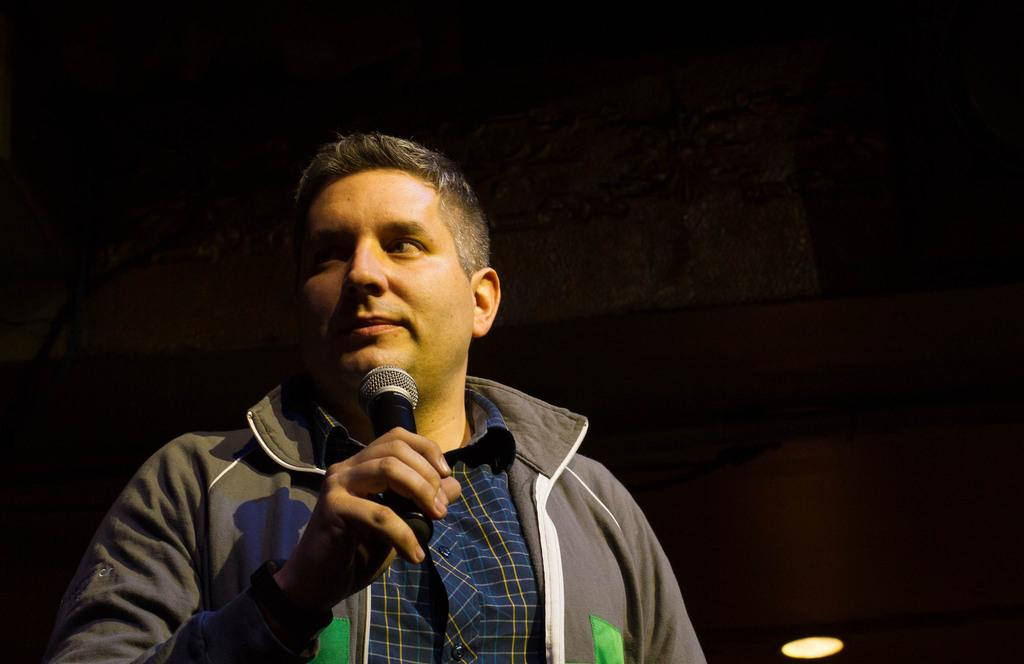What is the main subject in the foreground of the image? There is a person in the foreground of the image. What is the person doing in the image? The person is standing and holding a microphone in his hand. What can be observed about the background of the image? The background of the image is dark in color. What is visible at the bottom of the image? Light is visible at the bottom of the image. When was the image taken? The image was taken during night time. Can you see any fog in the image? There is no fog visible in the image. What type of crime is being committed in the image? There is no crime being committed in the image; it features a person holding a microphone. 